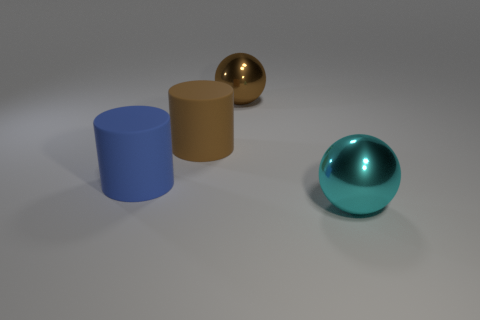Add 3 large cyan objects. How many objects exist? 7 Subtract 0 red cubes. How many objects are left? 4 Subtract all brown matte cylinders. Subtract all cyan spheres. How many objects are left? 2 Add 1 brown metallic balls. How many brown metallic balls are left? 2 Add 3 yellow cylinders. How many yellow cylinders exist? 3 